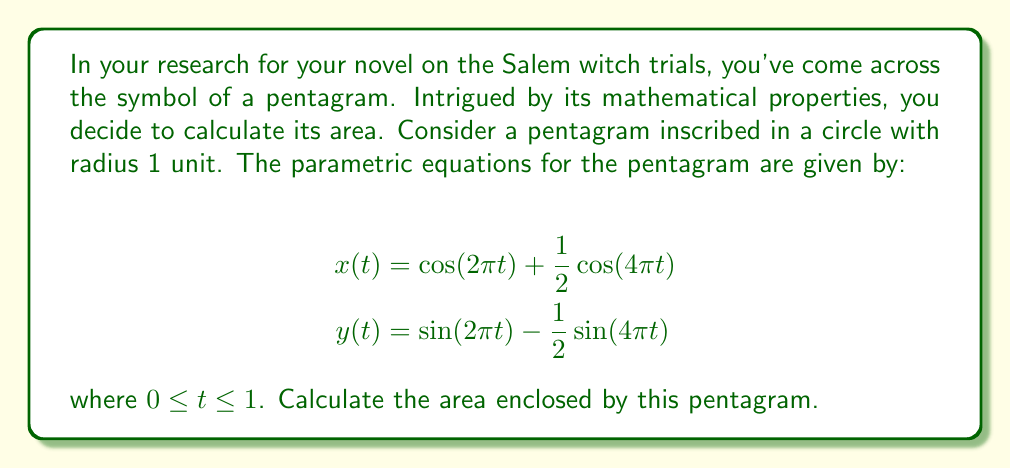Can you solve this math problem? To calculate the area enclosed by the pentagram, we can use Green's theorem, which relates a line integral around a simple closed curve to a double integral over the plane region it encloses. The formula for the area using parametric equations is:

$$A = \frac{1}{2}\int_0^1 [x(t)y'(t) - y(t)x'(t)] dt$$

Let's follow these steps:

1) First, we need to find $x'(t)$ and $y'(t)$:
   $$x'(t) = -2\pi\sin(2\pi t) - 2\pi\sin(4\pi t)$$
   $$y'(t) = 2\pi\cos(2\pi t) - 2\pi\cos(4\pi t)$$

2) Now, let's substitute these into our area formula:
   $$A = \frac{1}{2}\int_0^1 [(\cos(2\pi t) + \frac{1}{2}\cos(4\pi t))(2\pi\cos(2\pi t) - 2\pi\cos(4\pi t)) - (\sin(2\pi t) - \frac{1}{2}\sin(4\pi t))(-2\pi\sin(2\pi t) - 2\pi\sin(4\pi t))] dt$$

3) Expand this expression:
   $$A = \pi\int_0^1 [\cos^2(2\pi t) - \frac{1}{2}\cos(2\pi t)\cos(4\pi t) + \frac{1}{2}\cos(2\pi t)\cos(4\pi t) - \frac{1}{4}\cos^2(4\pi t) + \sin^2(2\pi t) + \frac{1}{2}\sin(2\pi t)\sin(4\pi t)] dt$$

4) Simplify:
   $$A = \pi\int_0^1 [\cos^2(2\pi t) + \sin^2(2\pi t) - \frac{1}{4}\cos^2(4\pi t) + \frac{1}{2}\sin(2\pi t)\sin(4\pi t)] dt$$

5) Use trigonometric identities:
   $$\cos^2(2\pi t) + \sin^2(2\pi t) = 1$$
   $$\cos^2(4\pi t) = \frac{1}{2}(1 + \cos(8\pi t))$$
   $$\sin(2\pi t)\sin(4\pi t) = \frac{1}{2}[\cos(2\pi t) - \cos(6\pi t)]$$

6) Substitute these identities:
   $$A = \pi\int_0^1 [1 - \frac{1}{8}(1 + \cos(8\pi t)) + \frac{1}{4}(\cos(2\pi t) - \cos(6\pi t))] dt$$

7) Integrate:
   $$A = \pi[t - \frac{1}{8}t - \frac{1}{64\pi}\sin(8\pi t) + \frac{1}{8\pi}\sin(2\pi t) + \frac{1}{24\pi}\sin(6\pi t)]_0^1$$

8) Evaluate the integral from 0 to 1:
   $$A = \pi(1 - \frac{1}{8}) = \frac{7\pi}{8}$$

Therefore, the area enclosed by the pentagram is $\frac{7\pi}{8}$ square units.
Answer: $$\frac{7\pi}{8}$$ square units 